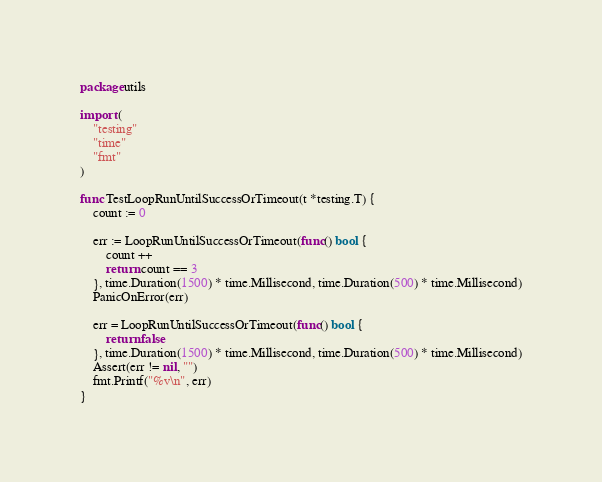Convert code to text. <code><loc_0><loc_0><loc_500><loc_500><_Go_>package utils

import (
	"testing"
	"time"
	"fmt"
)

func TestLoopRunUntilSuccessOrTimeout(t *testing.T) {
	count := 0

	err := LoopRunUntilSuccessOrTimeout(func() bool {
		count ++
		return count == 3
	}, time.Duration(1500) * time.Millisecond, time.Duration(500) * time.Millisecond)
	PanicOnError(err)

	err = LoopRunUntilSuccessOrTimeout(func() bool {
		return false
	}, time.Duration(1500) * time.Millisecond, time.Duration(500) * time.Millisecond)
	Assert(err != nil, "")
	fmt.Printf("%v\n", err)
}
</code> 